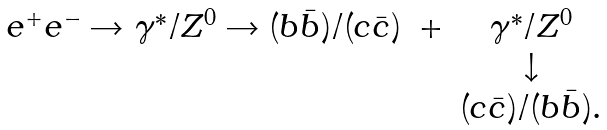Convert formula to latex. <formula><loc_0><loc_0><loc_500><loc_500>\begin{array} { l c c } e ^ { + } e ^ { - } \rightarrow \gamma ^ { * } / Z ^ { 0 } \rightarrow ( b \bar { b } ) / ( c \bar { c } ) & + & \gamma ^ { * } / Z ^ { 0 } \\ & & \downarrow \\ & & ( c \bar { c } ) / ( b \bar { b } ) . \end{array}</formula> 